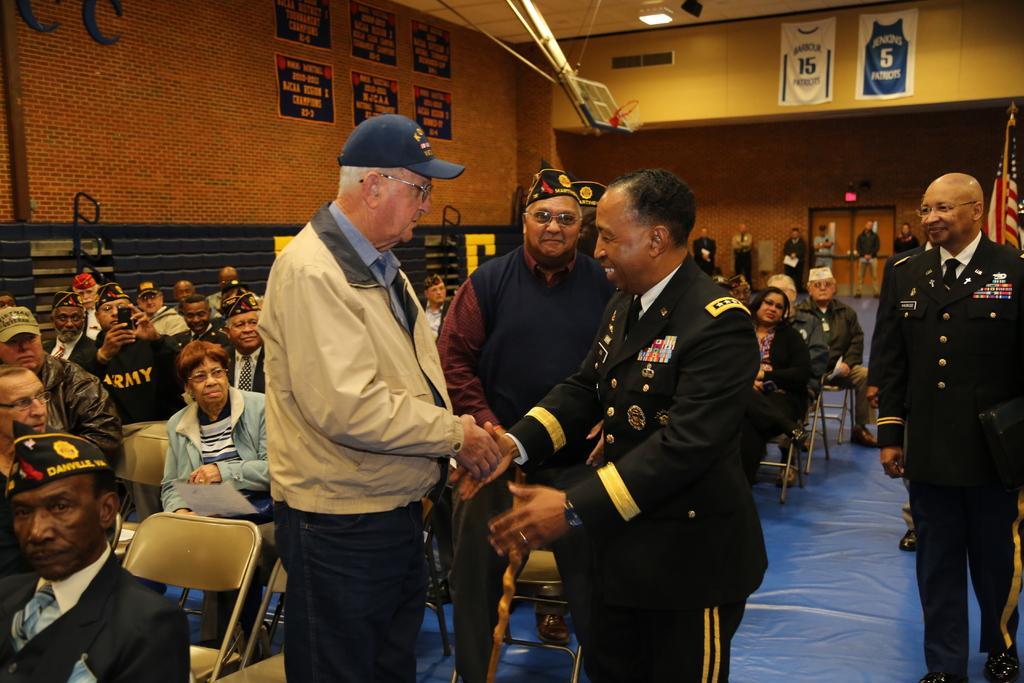Could you give a brief overview of what you see in this image? In this image we can see a group of people, some of them are sitting in the chairs and some of them are standing, the person who is sitting in the chair is holding a cell phone and taking a picture of the person who were standing, in the room there is a flag, on the top there are two posters. 